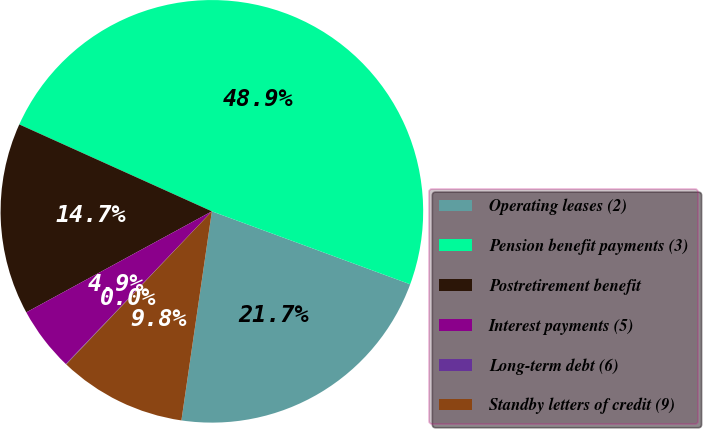<chart> <loc_0><loc_0><loc_500><loc_500><pie_chart><fcel>Operating leases (2)<fcel>Pension benefit payments (3)<fcel>Postretirement benefit<fcel>Interest payments (5)<fcel>Long-term debt (6)<fcel>Standby letters of credit (9)<nl><fcel>21.69%<fcel>48.86%<fcel>14.68%<fcel>4.92%<fcel>0.04%<fcel>9.8%<nl></chart> 